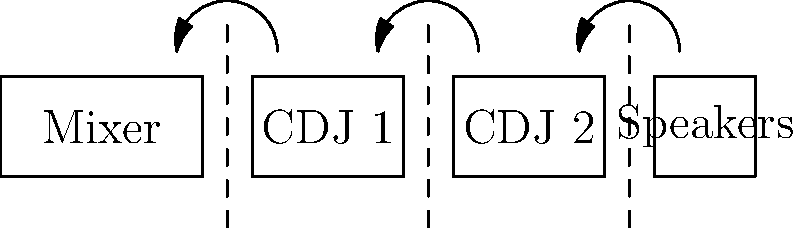A compact DJ setup needs to be folded for transportation. The diagram shows the unfolded setup with folding lines. If the setup is folded inward along these lines, which component will be on top when fully folded? To determine which component will be on top when the setup is fully folded, we need to follow the folding process step by step:

1. The setup consists of four components from left to right: Mixer, CDJ 1, CDJ 2, and Speakers.
2. There are three folding lines indicated by dashed lines in the diagram.
3. The arrows show that each section folds inward (from right to left) along these lines.
4. Folding process:
   a. First fold: Speakers fold over CDJ 2
   b. Second fold: Speakers and CDJ 2 fold over CDJ 1
   c. Third fold: Speakers, CDJ 2, and CDJ 1 fold over the Mixer
5. After completing all folds, the stack order from bottom to top will be:
   Mixer (bottom) -> CDJ 1 -> CDJ 2 -> Speakers (top)

Therefore, the Speakers will be on top when the setup is fully folded.
Answer: Speakers 